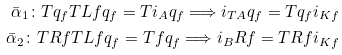<formula> <loc_0><loc_0><loc_500><loc_500>\bar { \alpha } _ { 1 } \colon T q _ { f } T { L } f q _ { f } = T i _ { A } q _ { f } \Longrightarrow i _ { T A } q _ { f } = T q _ { f } i _ { K f } \\ \bar { \alpha } _ { 2 } \colon T { R } f T { L } f q _ { f } = T f q _ { f } \Longrightarrow i _ { B } { R } f = T { R } f i _ { K f }</formula> 